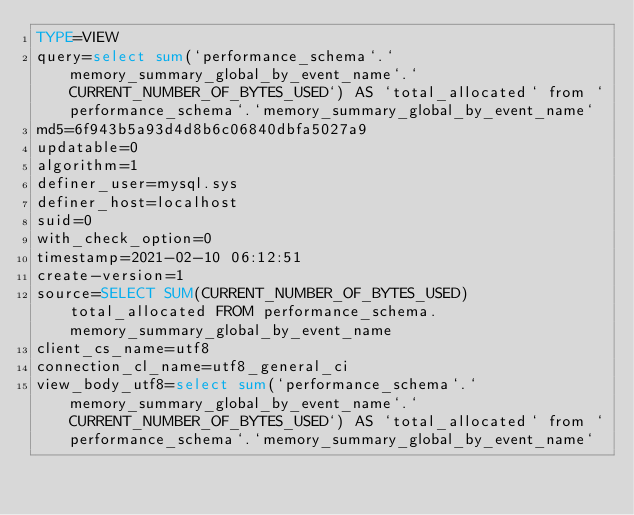Convert code to text. <code><loc_0><loc_0><loc_500><loc_500><_VisualBasic_>TYPE=VIEW
query=select sum(`performance_schema`.`memory_summary_global_by_event_name`.`CURRENT_NUMBER_OF_BYTES_USED`) AS `total_allocated` from `performance_schema`.`memory_summary_global_by_event_name`
md5=6f943b5a93d4d8b6c06840dbfa5027a9
updatable=0
algorithm=1
definer_user=mysql.sys
definer_host=localhost
suid=0
with_check_option=0
timestamp=2021-02-10 06:12:51
create-version=1
source=SELECT SUM(CURRENT_NUMBER_OF_BYTES_USED) total_allocated FROM performance_schema.memory_summary_global_by_event_name
client_cs_name=utf8
connection_cl_name=utf8_general_ci
view_body_utf8=select sum(`performance_schema`.`memory_summary_global_by_event_name`.`CURRENT_NUMBER_OF_BYTES_USED`) AS `total_allocated` from `performance_schema`.`memory_summary_global_by_event_name`
</code> 